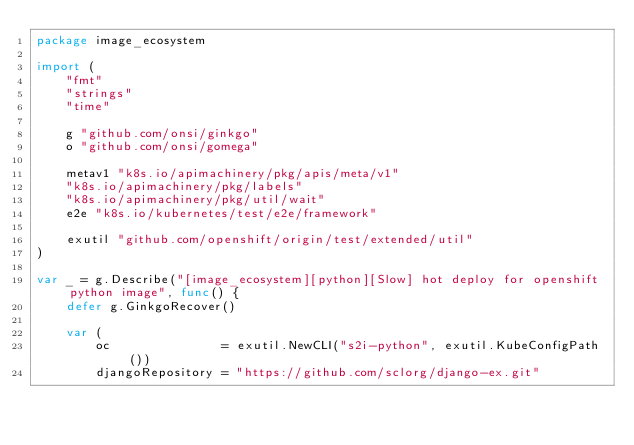Convert code to text. <code><loc_0><loc_0><loc_500><loc_500><_Go_>package image_ecosystem

import (
	"fmt"
	"strings"
	"time"

	g "github.com/onsi/ginkgo"
	o "github.com/onsi/gomega"

	metav1 "k8s.io/apimachinery/pkg/apis/meta/v1"
	"k8s.io/apimachinery/pkg/labels"
	"k8s.io/apimachinery/pkg/util/wait"
	e2e "k8s.io/kubernetes/test/e2e/framework"

	exutil "github.com/openshift/origin/test/extended/util"
)

var _ = g.Describe("[image_ecosystem][python][Slow] hot deploy for openshift python image", func() {
	defer g.GinkgoRecover()

	var (
		oc               = exutil.NewCLI("s2i-python", exutil.KubeConfigPath())
		djangoRepository = "https://github.com/sclorg/django-ex.git"</code> 